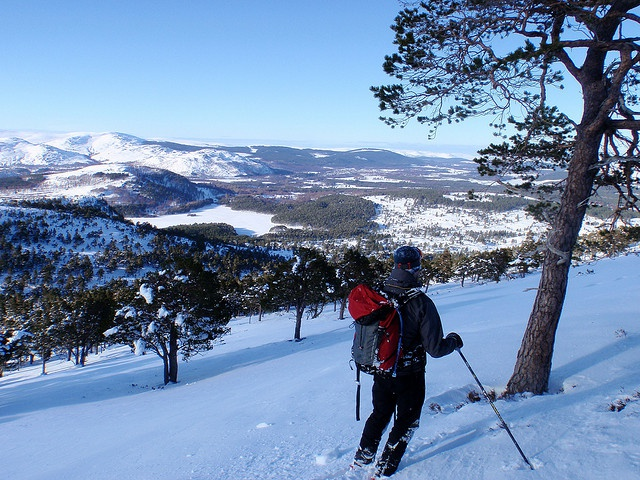Describe the objects in this image and their specific colors. I can see people in lightblue, black, navy, darkgray, and gray tones, backpack in lightblue, black, navy, darkblue, and maroon tones, and skis in lightblue, darkgray, and gray tones in this image. 